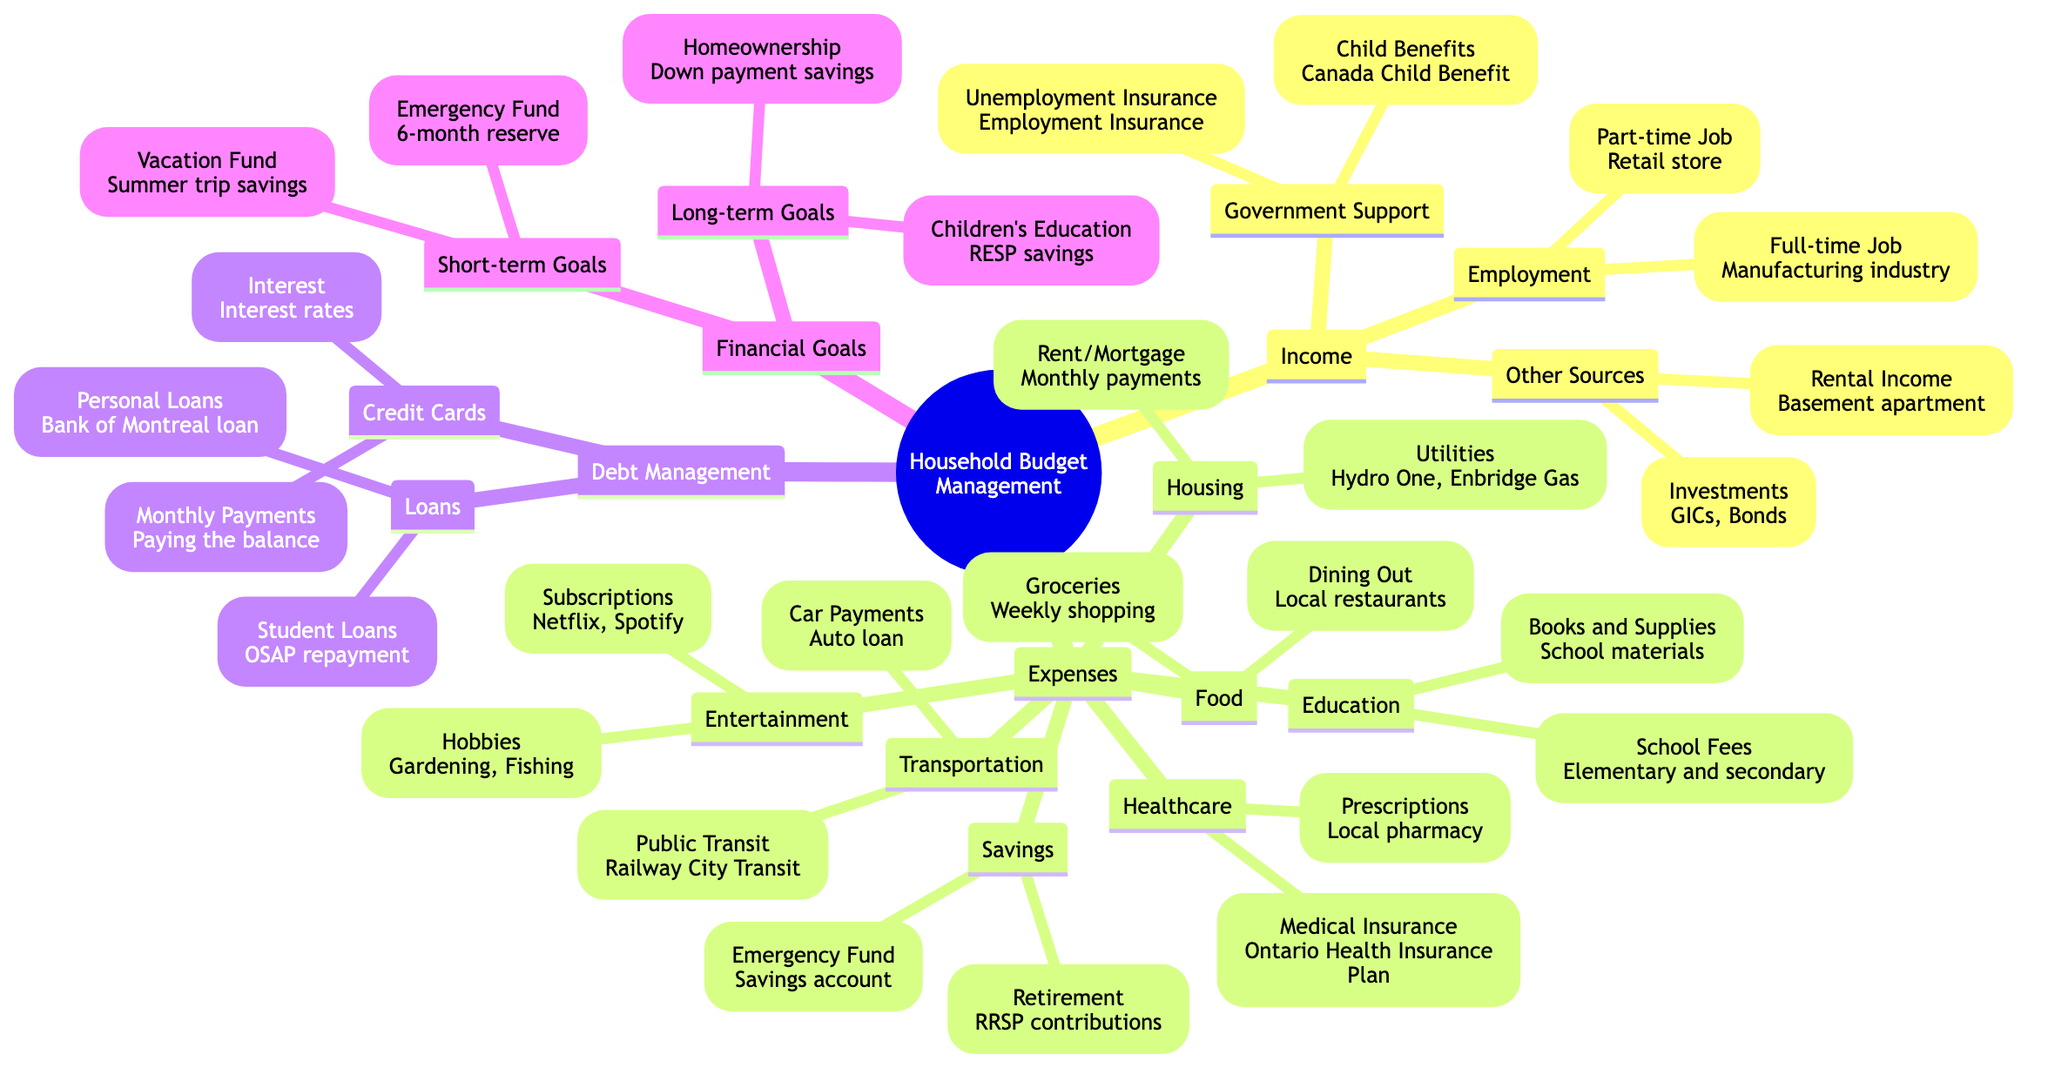What's included under "Income"? The "Income" node has three subcategories: "Employment," "Government Support," and "Other Sources." Each of these categories contains specific sources of income such as jobs and government benefits.
Answer: Employment, Government Support, Other Sources How many types of expenses are listed? In the "Expenses" section, there are six main categories: Housing, Food, Transportation, Healthcare, Education, Savings, and Entertainment. Therefore, there are seven types of expenses listed.
Answer: 7 What is the source of "Child Benefits"? Under the "Government Support" category, the "Child Benefits" are specified as "Canada Child Benefit." This directly names the source associated with child benefits.
Answer: Canada Child Benefit Which category does "Emergency Fund" fall under? The "Emergency Fund" is listed under the "Savings" section of the "Expenses" category, indicating it is a type of saving goal.
Answer: Savings What are the short-term financial goals mentioned? The short-term financial goals include two items: "Vacation Fund" and "Emergency Fund Completion." This shows specific saving objectives within short-term timeframes.
Answer: Vacation Fund, Emergency Fund Completion How are "Car Payments" categorized? "Car Payments" are located under the "Transportation" category in the "Expenses" section, indicating that they are an expense associated with transportation.
Answer: Transportation How is "Prescriptions" defined in the diagram? "Prescriptions" are mentioned in the "Healthcare" section under Expenses, specifically associated with the "Local pharmacy," highlighting where these expenses occur.
Answer: Local pharmacy What types of loans are indicated under "Loans" in Debt Management? The "Loans" section in the "Debt Management" branch includes two types: "Student Loans" and "Personal Loans," demonstrating different repayment obligations.
Answer: Student Loans, Personal Loans What is one of the long-term financial goals? The "Long-term Goals" section lists two goals, one of which is "Homeownership," indicating a significant financial aim related to property ownership.
Answer: Homeownership 